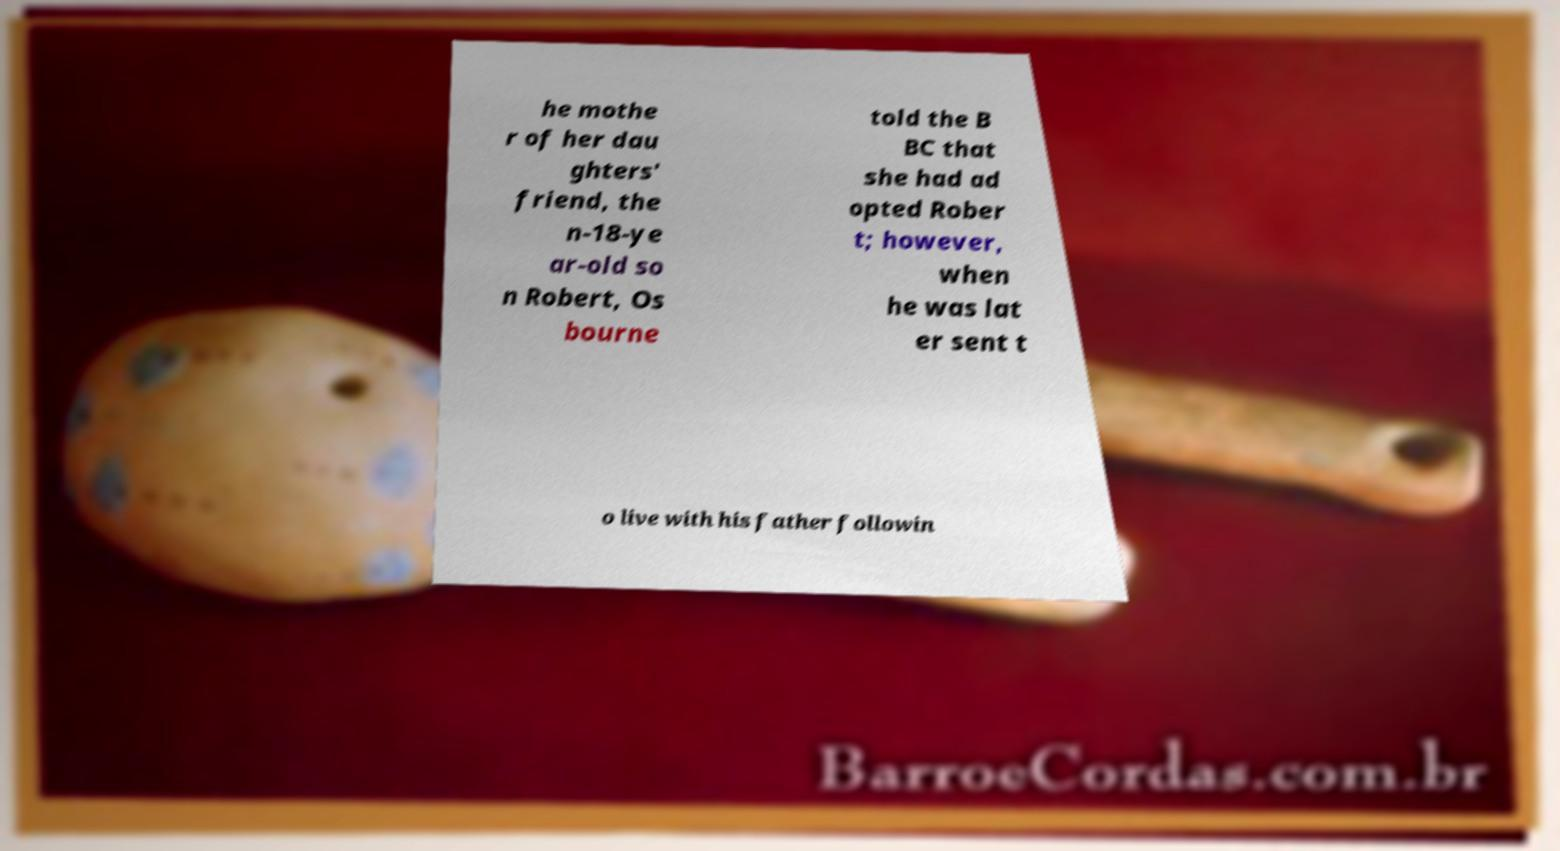I need the written content from this picture converted into text. Can you do that? he mothe r of her dau ghters' friend, the n-18-ye ar-old so n Robert, Os bourne told the B BC that she had ad opted Rober t; however, when he was lat er sent t o live with his father followin 